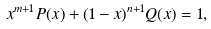Convert formula to latex. <formula><loc_0><loc_0><loc_500><loc_500>x ^ { m + 1 } P ( x ) + ( 1 - x ) ^ { n + 1 } Q ( x ) = 1 ,</formula> 